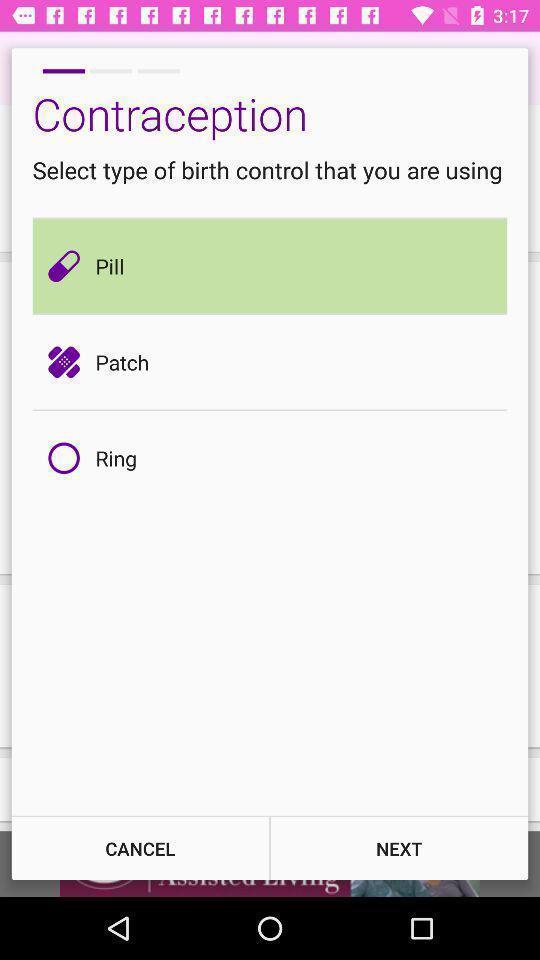Please provide a description for this image. Selecting birth control page of a period tracker. 